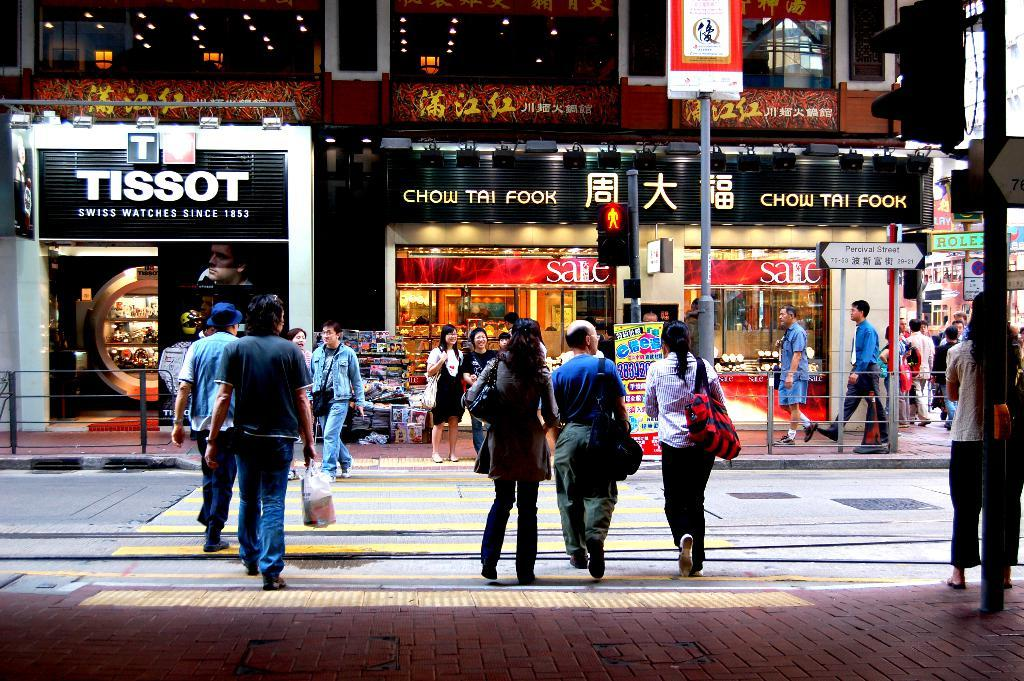Who or what is present in the image? There are people in the image. What can be seen in the foreground of the image? There is a road, boards, traffic signals, and poles in the image. What can be seen in the background of the image? There is a building, stores, a stall, and additional boards in the background of the image. What color is the crayon being used by the people in the image? There is no crayon present in the image; it features people, a road, boards, traffic signals, poles, a building, stores, a stall, and additional boards. 